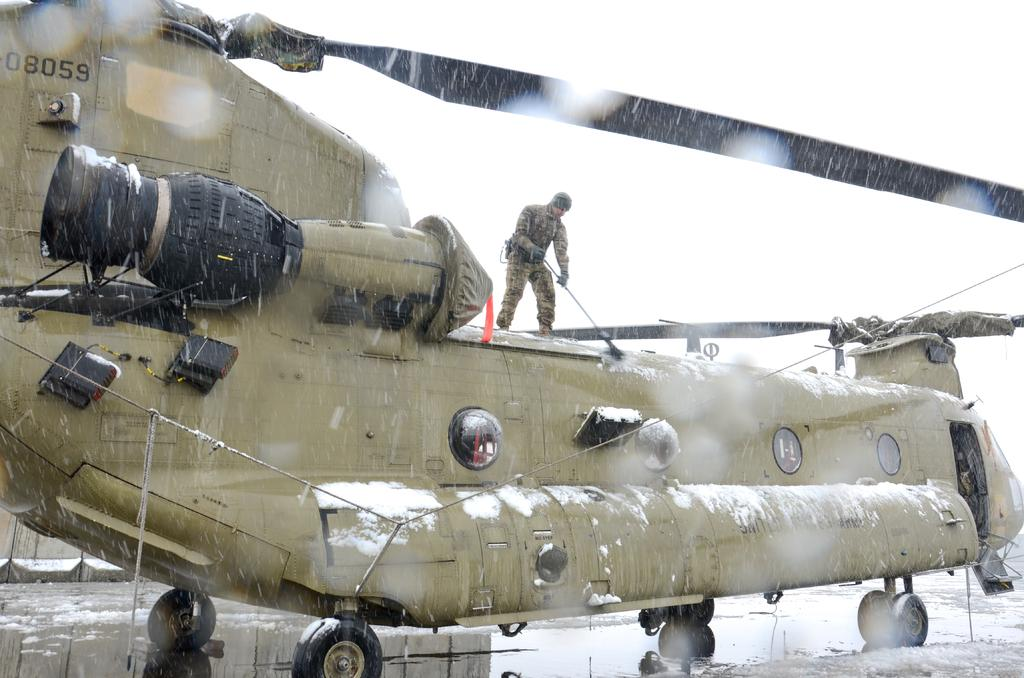<image>
Share a concise interpretation of the image provided. the numbers 8059 are on the back of the chopper 